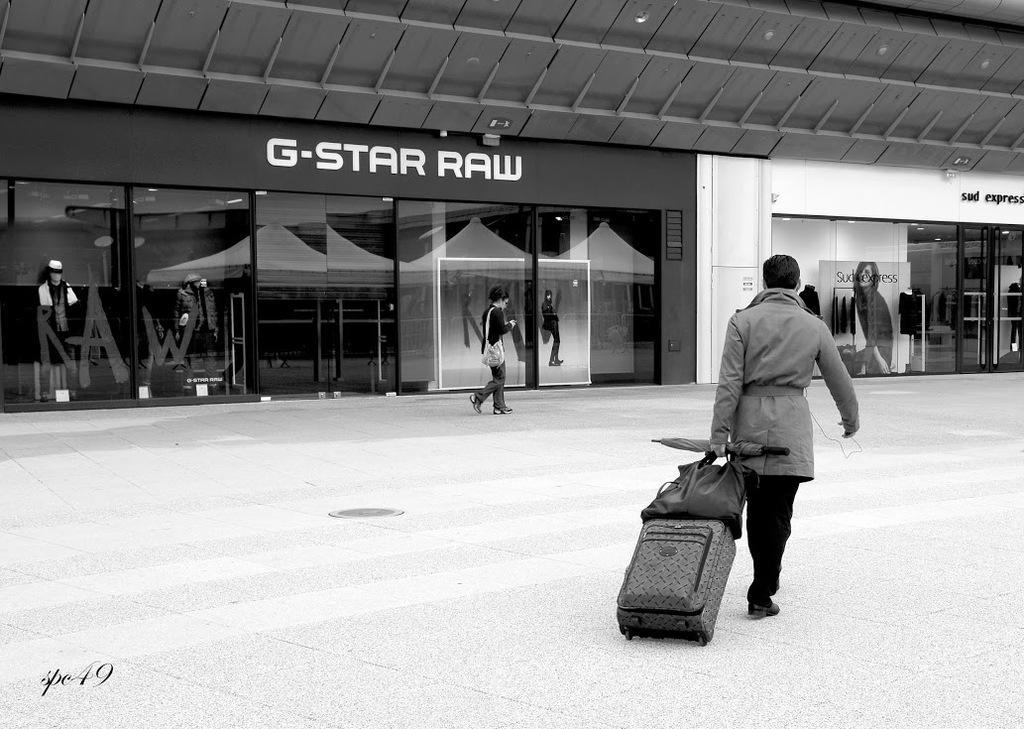Can you describe this image briefly? This is a black and white image. In the image there is a person walking and holding luggage in his hand and also there is an umbrella. There is a lady with a bag and she is walking. In the background there are glass walls. Behind the glasses there are mannequins. And also there are posters on the glass. And there are names on the walls. At the top of the image there is a ceiling with lights. 